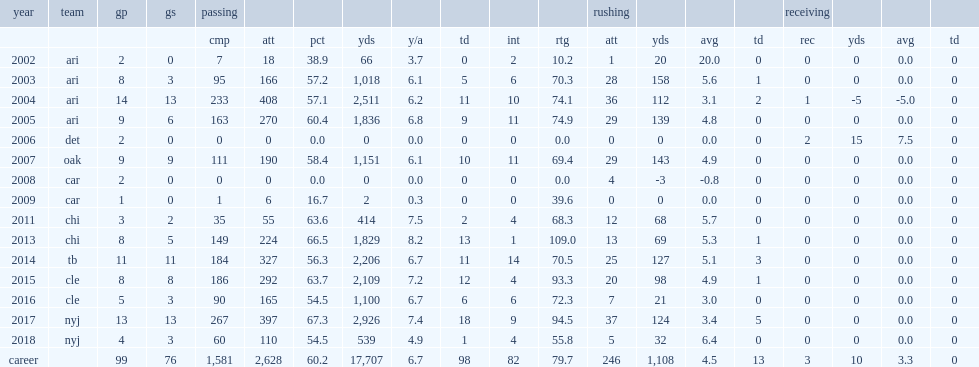How many rushing yards did josh mccown get in 2003? 158.0. 